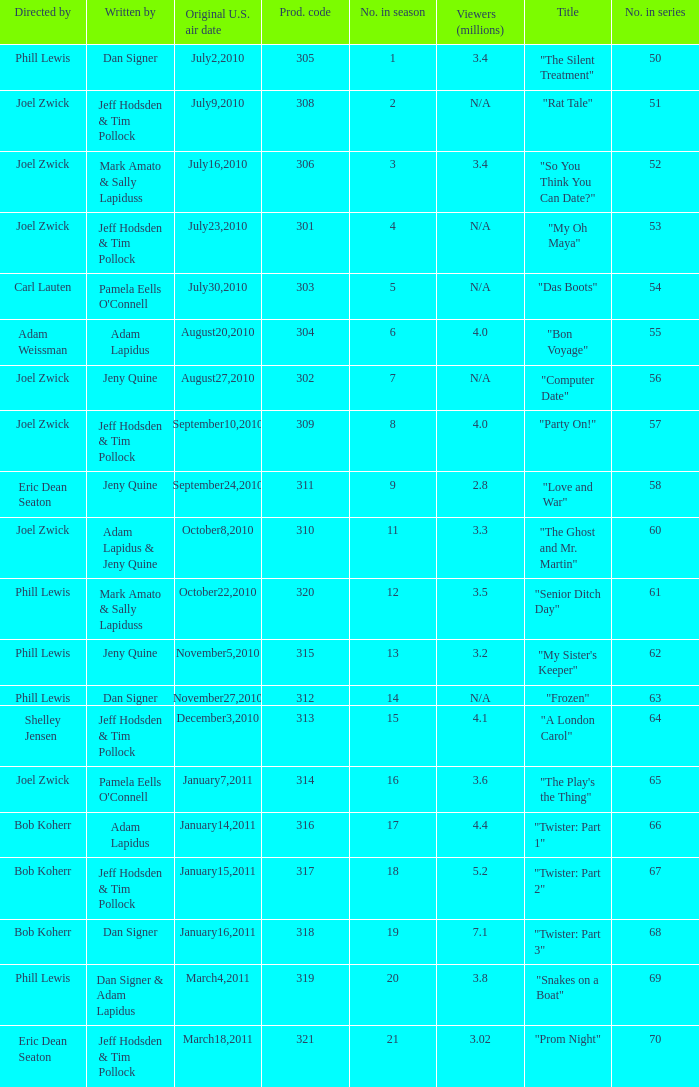Who was the directed for the episode titled "twister: part 1"? Bob Koherr. 